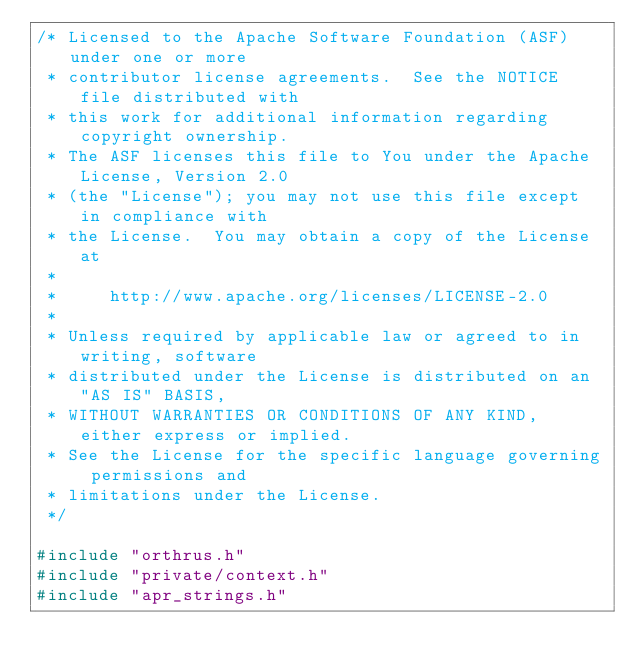<code> <loc_0><loc_0><loc_500><loc_500><_C_>/* Licensed to the Apache Software Foundation (ASF) under one or more
 * contributor license agreements.  See the NOTICE file distributed with
 * this work for additional information regarding copyright ownership.
 * The ASF licenses this file to You under the Apache License, Version 2.0
 * (the "License"); you may not use this file except in compliance with
 * the License.  You may obtain a copy of the License at
 *
 *     http://www.apache.org/licenses/LICENSE-2.0
 *
 * Unless required by applicable law or agreed to in writing, software
 * distributed under the License is distributed on an "AS IS" BASIS,
 * WITHOUT WARRANTIES OR CONDITIONS OF ANY KIND, either express or implied.
 * See the License for the specific language governing permissions and
 * limitations under the License.
 */

#include "orthrus.h"
#include "private/context.h"
#include "apr_strings.h"</code> 